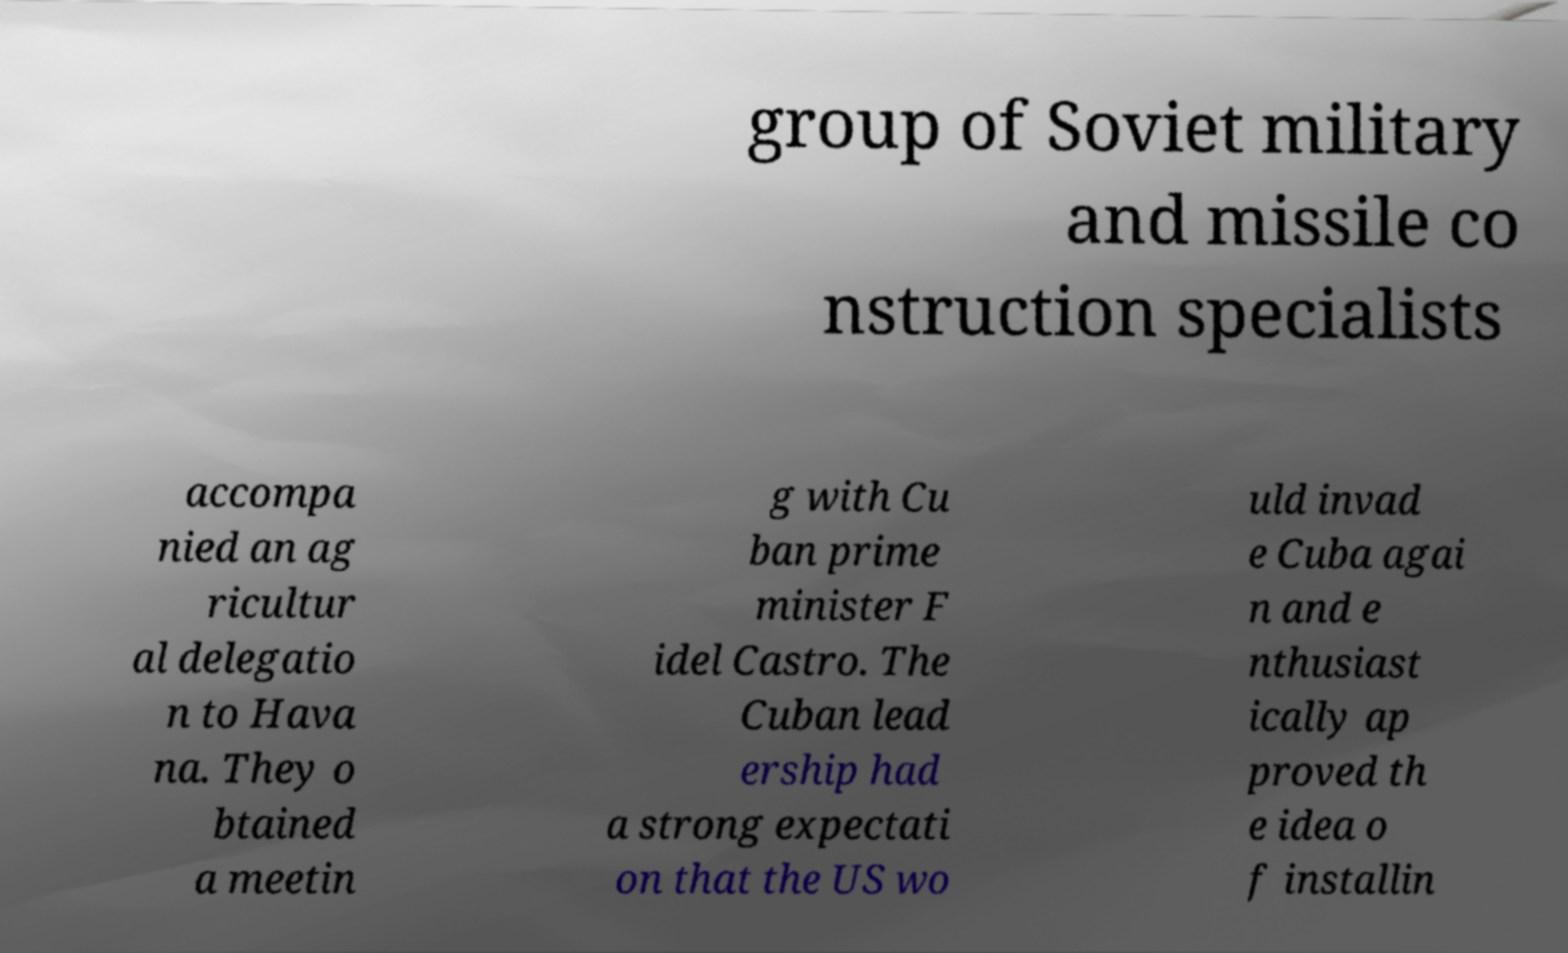Could you extract and type out the text from this image? group of Soviet military and missile co nstruction specialists accompa nied an ag ricultur al delegatio n to Hava na. They o btained a meetin g with Cu ban prime minister F idel Castro. The Cuban lead ership had a strong expectati on that the US wo uld invad e Cuba agai n and e nthusiast ically ap proved th e idea o f installin 